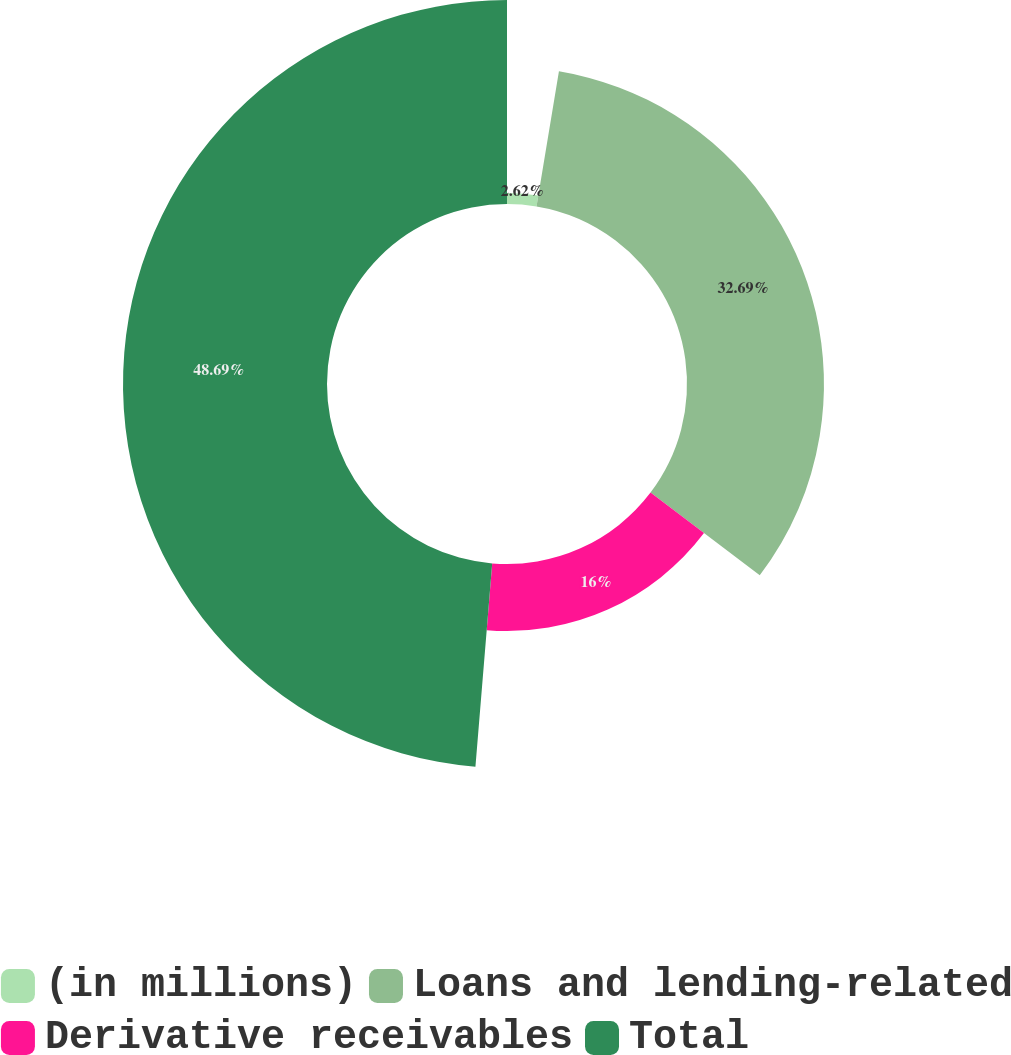Convert chart to OTSL. <chart><loc_0><loc_0><loc_500><loc_500><pie_chart><fcel>(in millions)<fcel>Loans and lending-related<fcel>Derivative receivables<fcel>Total<nl><fcel>2.62%<fcel>32.69%<fcel>16.0%<fcel>48.69%<nl></chart> 